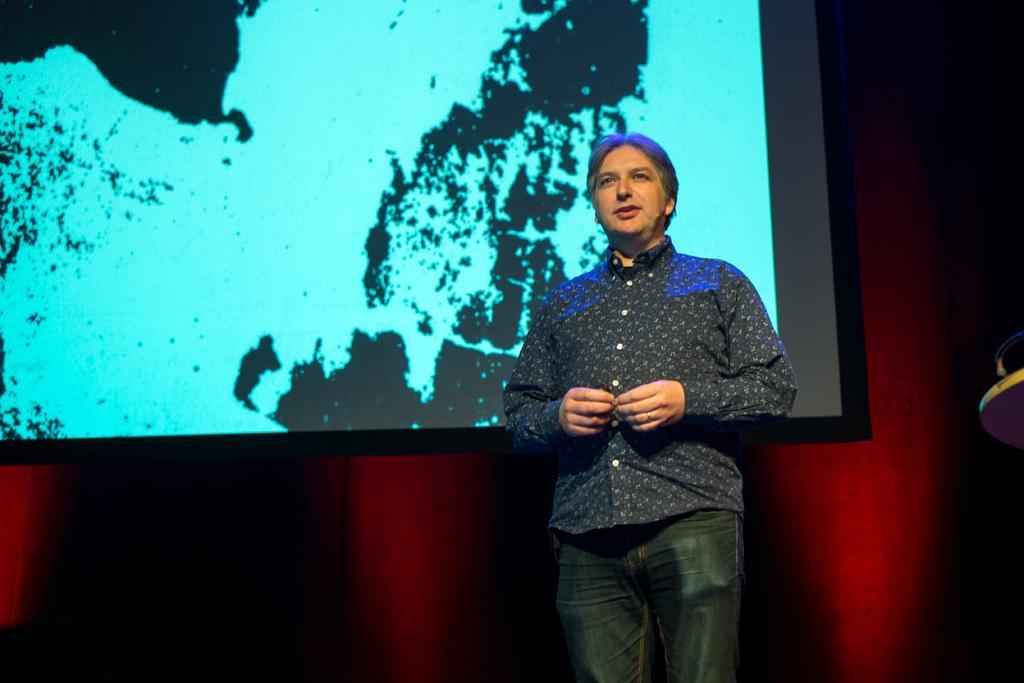Can you describe this image briefly? In this image we can see a person standing. In the background there is a screen attached to the wall. 